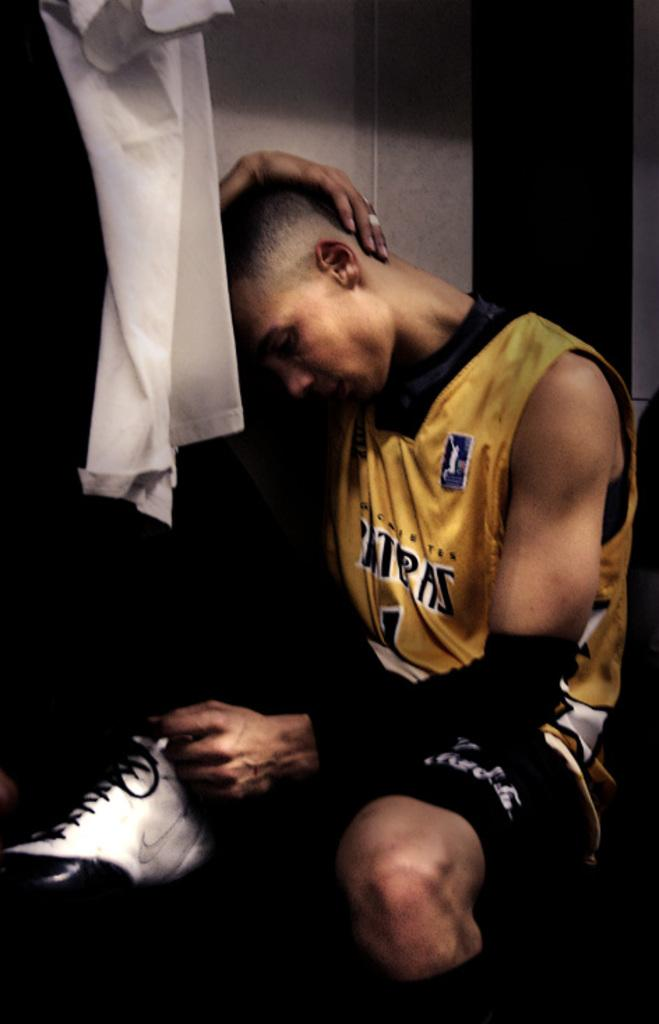What is the main subject in the foreground of the image? There is a man in the foreground of the image. What is the man doing in the image? The man is sitting in the image. What is the man doing with one of his hands? The man has one hand on his head in the image. What can be seen on the left top of the image? There is a cloth on the left top of the image. What is behind the man in the image? There is a wall behind the man in the image. What type of fork is the man using to comb his hair in the image? There is no fork present in the image, and the man is not shown combing his hair. 